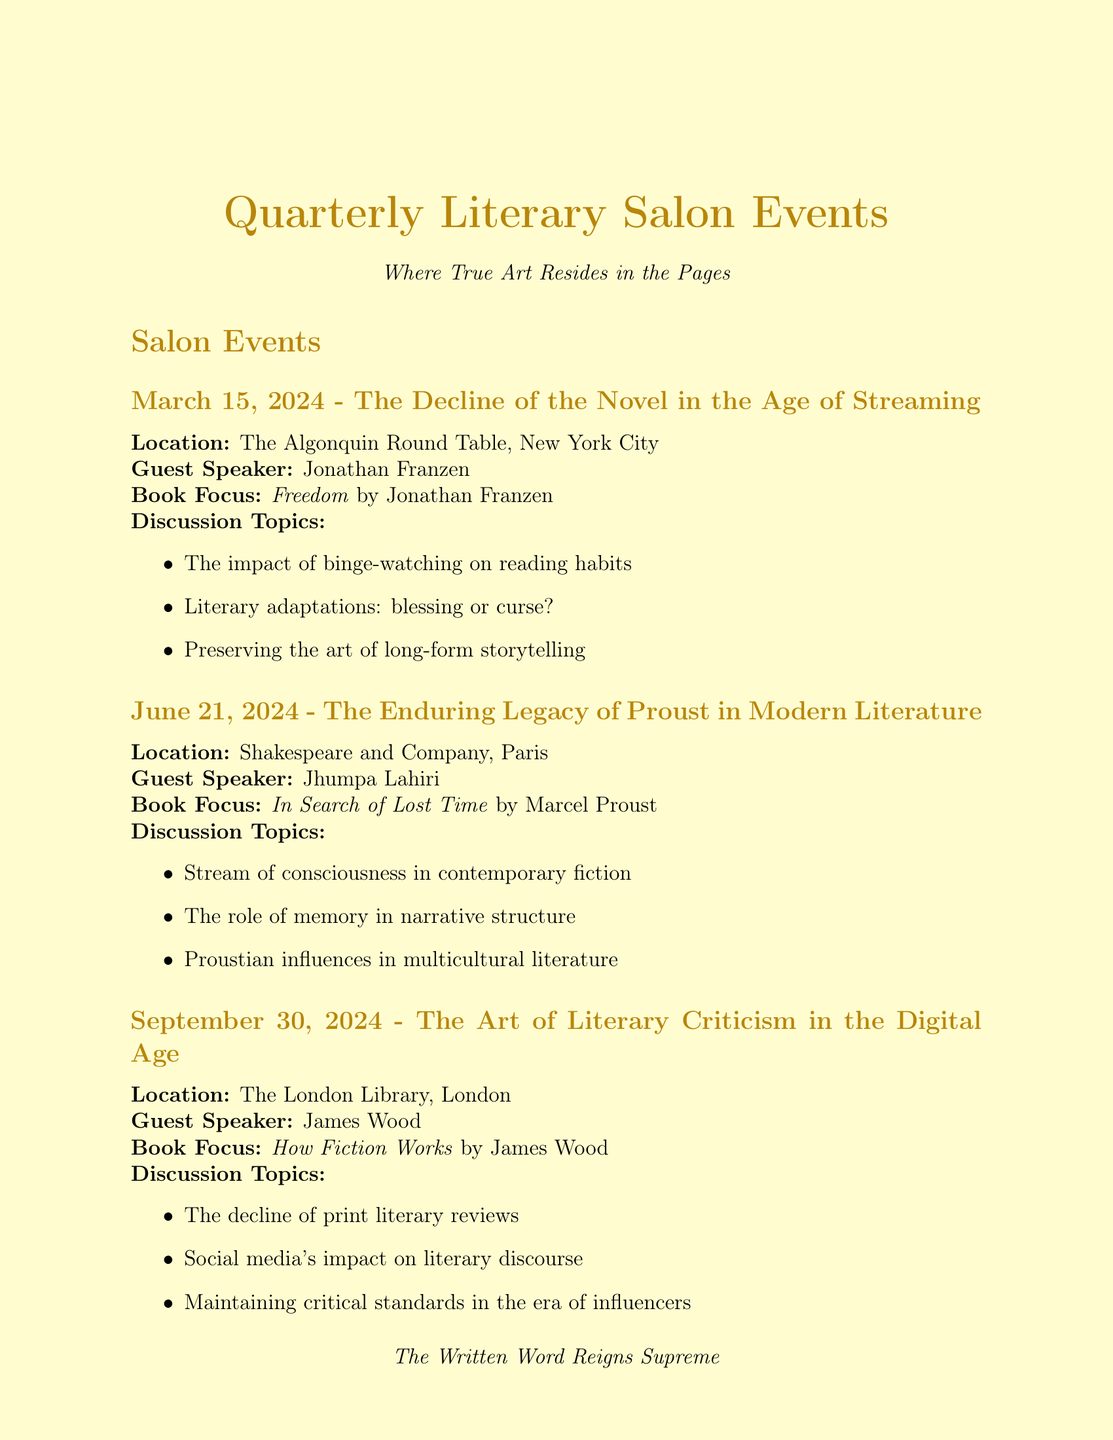What is the date of the first salon event? The first salon event is on March 15, 2024, as stated in the schedule.
Answer: March 15, 2024 Who is the guest speaker for the June salon event? The guest speaker for the June salon event is mentioned as Jhumpa Lahiri in the document.
Answer: Jhumpa Lahiri What is the theme of the September salon event? The theme for the September salon event is specified as "The Art of Literary Criticism in the Digital Age."
Answer: The Art of Literary Criticism in the Digital Age Where is the Annual Booker Prize Shortlist Debate held? The location for the Annual Booker Prize Shortlist Debate is stated as The British Library, London.
Answer: The British Library, London What is the focus book for the December salon event? The book focus for the December salon event is mentioned as "Lincoln in the Bardo" by George Saunders.
Answer: Lincoln in the Bardo by George Saunders What does the ongoing initiative "Quarterly Essay Contest" focus on? The focus of the Quarterly Essay Contest, as noted in the document, is on "The Superiority of Literature over Other Narrative Forms."
Answer: The Superiority of Literature over Other Narrative Forms Who is the instructor for the workshop in July? The instructor for the workshop is specified as Marilynne Robinson in the information provided.
Answer: Marilynne Robinson Which event discusses the influence of social media on literary discourse? The salon event in September covers this topic, as stated in the discussion topics.
Answer: The Art of Literary Criticism in the Digital Age 